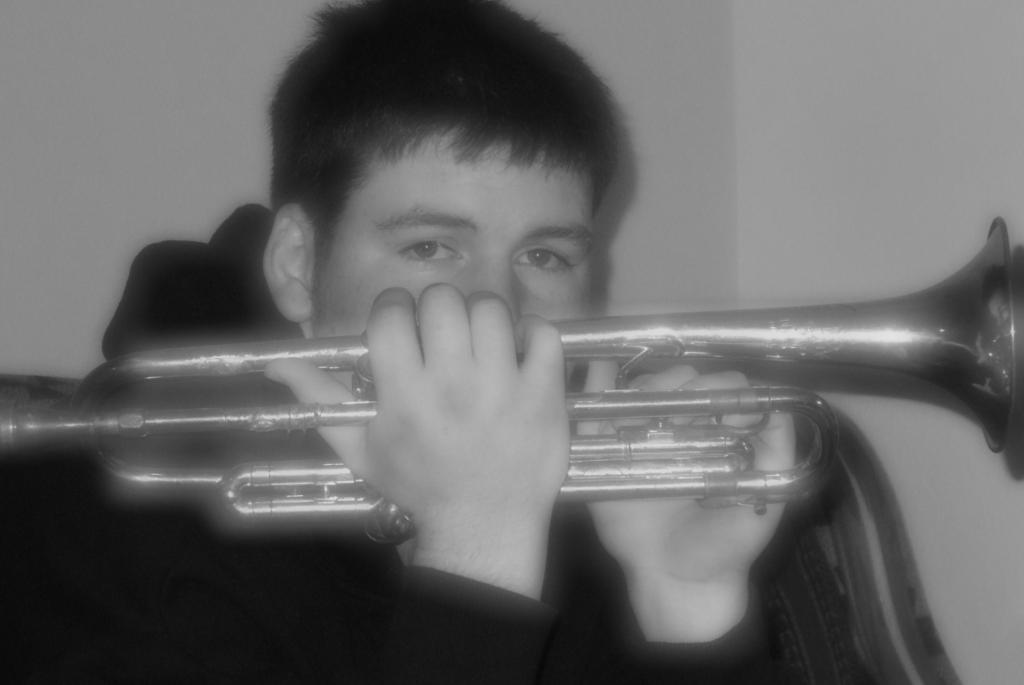What is the color scheme of the image? The image is black and white. Who is present in the image? There is a man in the image. What is the man holding in the image? The man is holding a trumpet. What is located behind the man? There is a chair behind the man. What is behind the chair? There is a wall behind the chair. How many girls are playing with the worm in the image? There are no girls or worms present in the image. Is there a flame visible in the image? No, there is no flame visible in the image. 